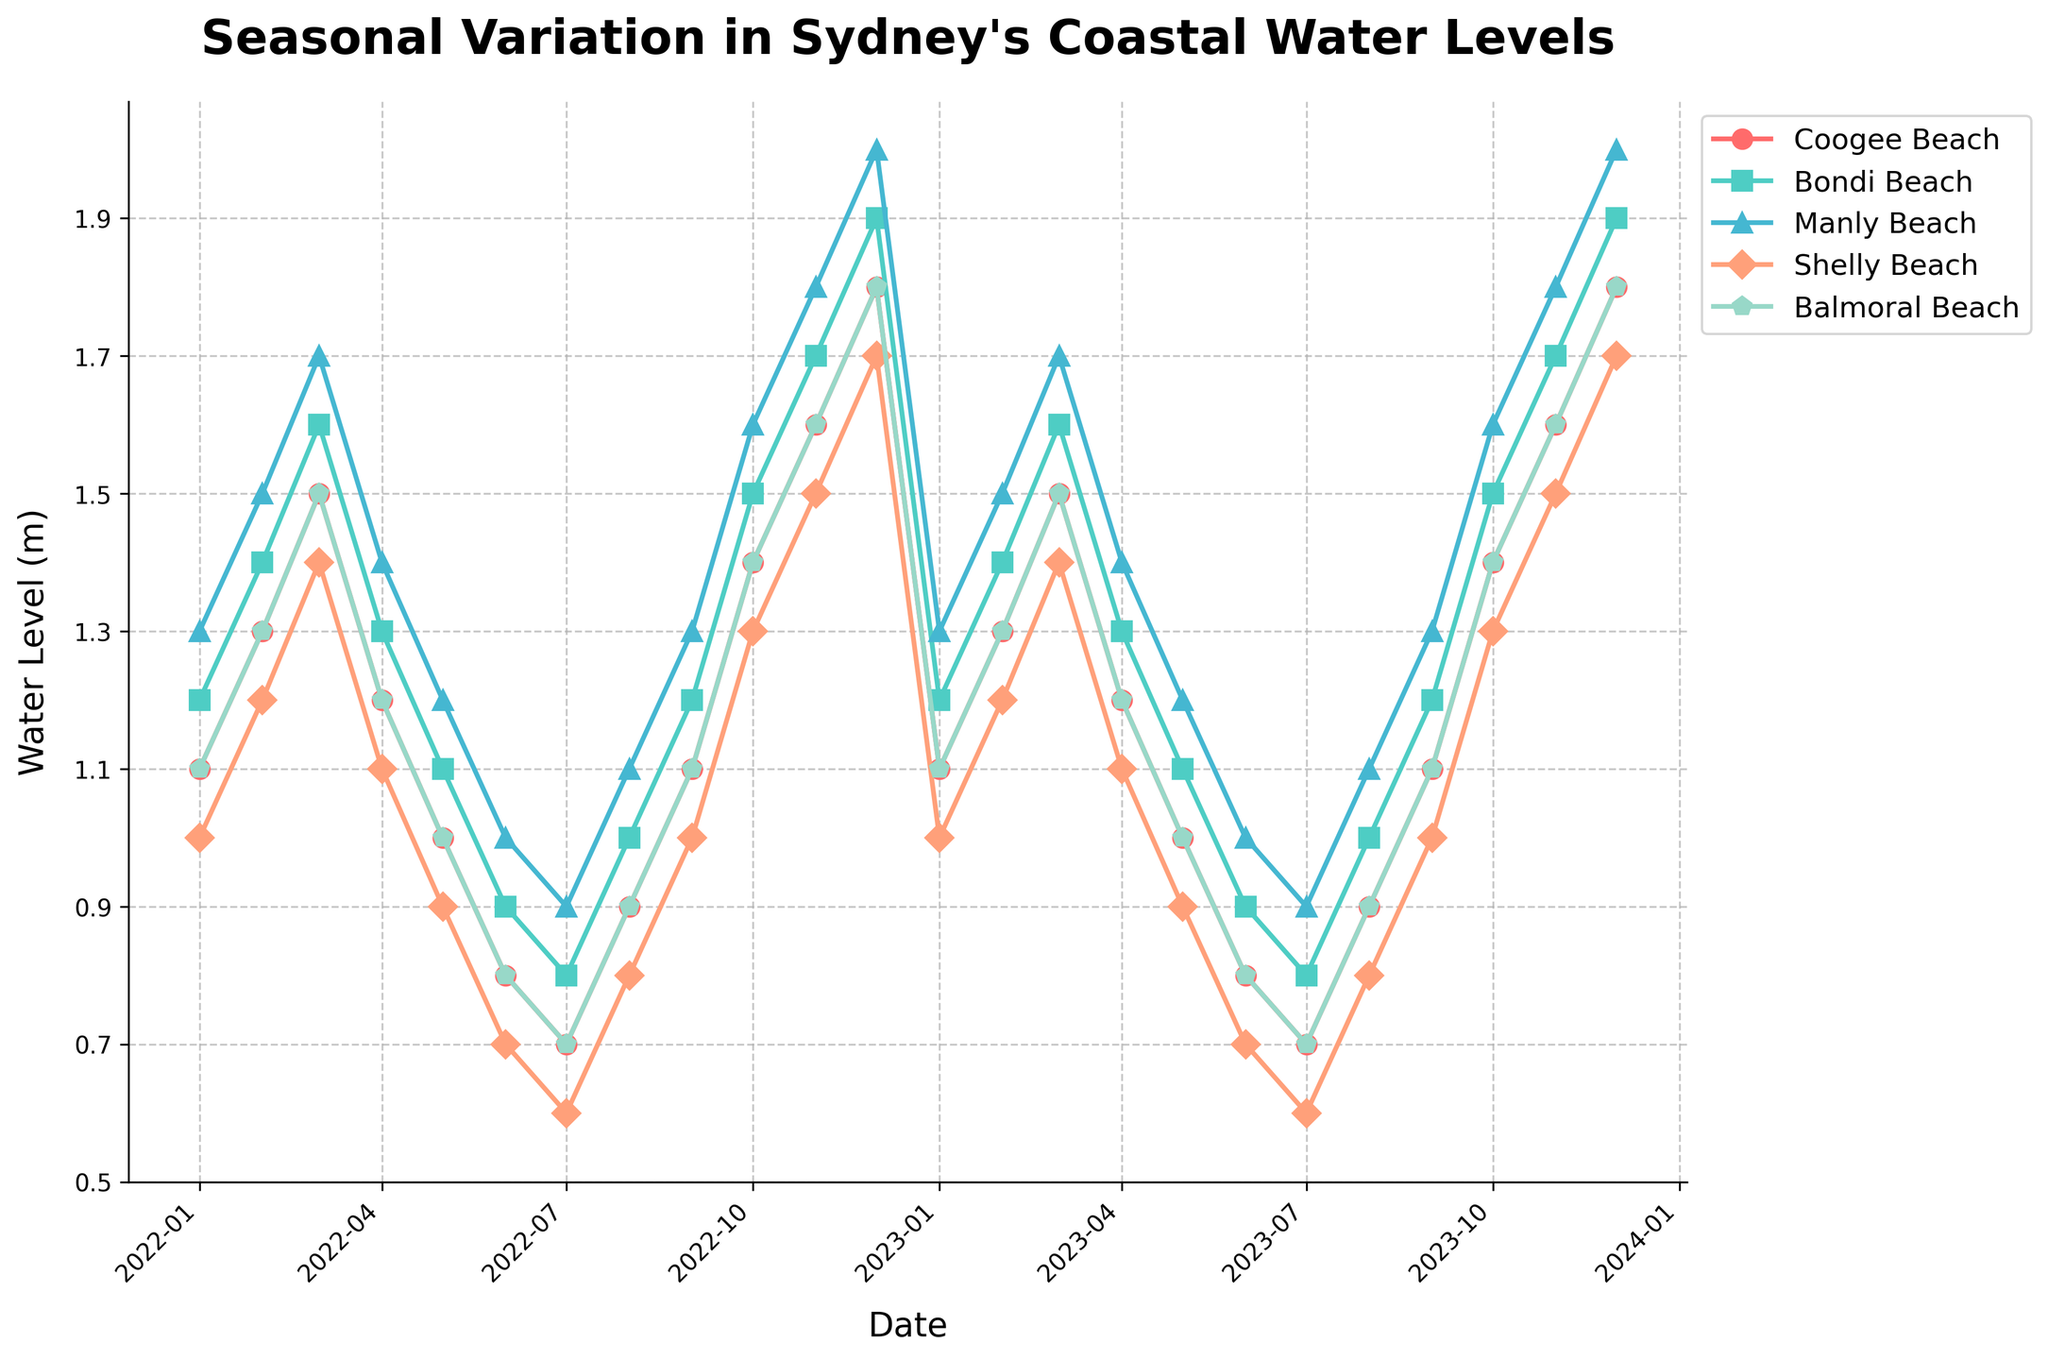What is the highest water level recorded at Manly Beach? The highest water level can be checked by observing the highest point on the Manly Beach line in the plot. The peak is reached on December 2022 and December 2023 at a water level of 2.0 meters.
Answer: 2.0 meters Which month shows the lowest water level across all beaches? By looking at the troughs of all lines representing each beach, July shows the lowest water levels for all beaches.
Answer: July How do the water levels at Bondi Beach in January 2022 compare to January 2023? To compare the water levels at Bondi Beach, check the points corresponding to January 2022 and January 2023 on the Bondi Beach line. Both points show a water level of 1.2 meters.
Answer: They are equal Which beach experienced the most significant increase in water level from February 2022 to March 2022? By comparing the slopes between February 2022 and March 2022 for each beach line, Manly Beach shows the steepest increase, from 1.5 meters to 1.7 meters.
Answer: Manly Beach Which beach has the most significant seasonal variation in water levels? To determine this, observe which line has the largest range between its highest and lowest points. Manly Beach ranges from 0.9 meters (July) to 2.0 meters (December).
Answer: Manly Beach How do water levels vary seasonally at Coogee Beach? To observe seasonal variation, follow the Coogee Beach line throughout the year. Water levels peak in the warmer months (November to March) and dip in cooler months (June to July). The pattern repeats similarly across both years.
Answer: Peak in warmer months, dip in cooler months In which month did Shelly Beach experience its maximum water level, and what was it? By identifying the highest point on the Shelly Beach line, the maximum water level in December 2022 and December 2023 is 1.7 meters.
Answer: December, 1.7 meters 